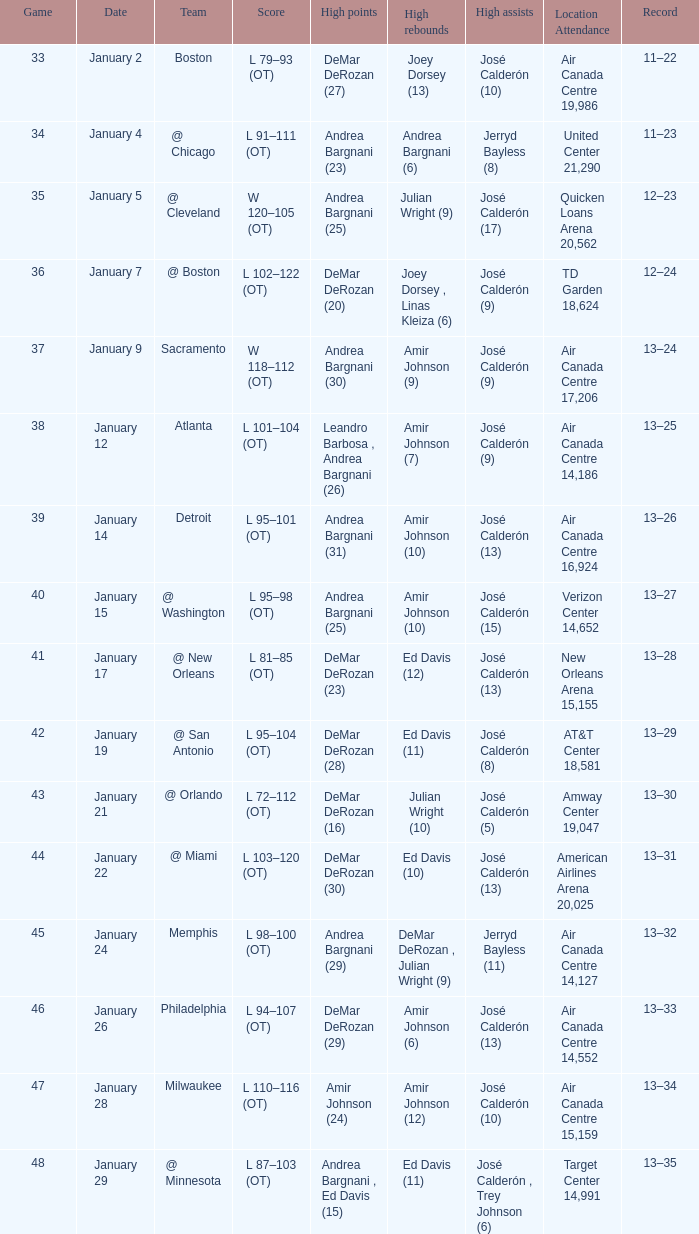Name the team for score l 102–122 (ot) @ Boston. 